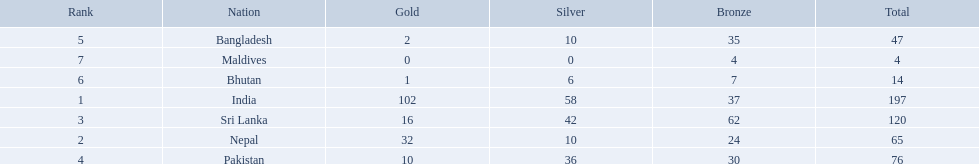What nations took part in 1999 south asian games? India, Nepal, Sri Lanka, Pakistan, Bangladesh, Bhutan, Maldives. Of those who earned gold medals? India, Nepal, Sri Lanka, Pakistan, Bangladesh, Bhutan. Which nation didn't earn any gold medals? Maldives. What were the total amount won of medals by nations in the 1999 south asian games? 197, 65, 120, 76, 47, 14, 4. Which amount was the lowest? 4. Which nation had this amount? Maldives. 